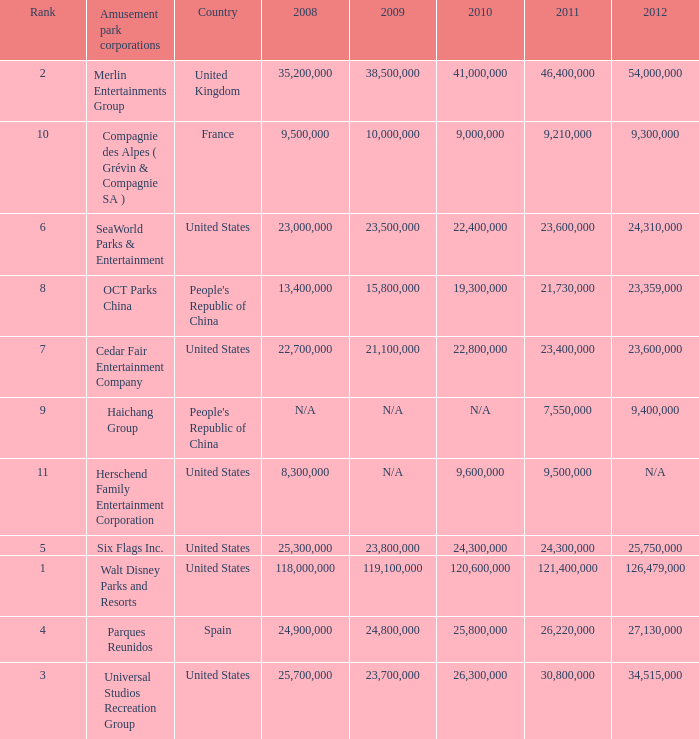What is the Rank listed for the attendance of 2010 of 9,000,000 and 2011 larger than 9,210,000? None. 